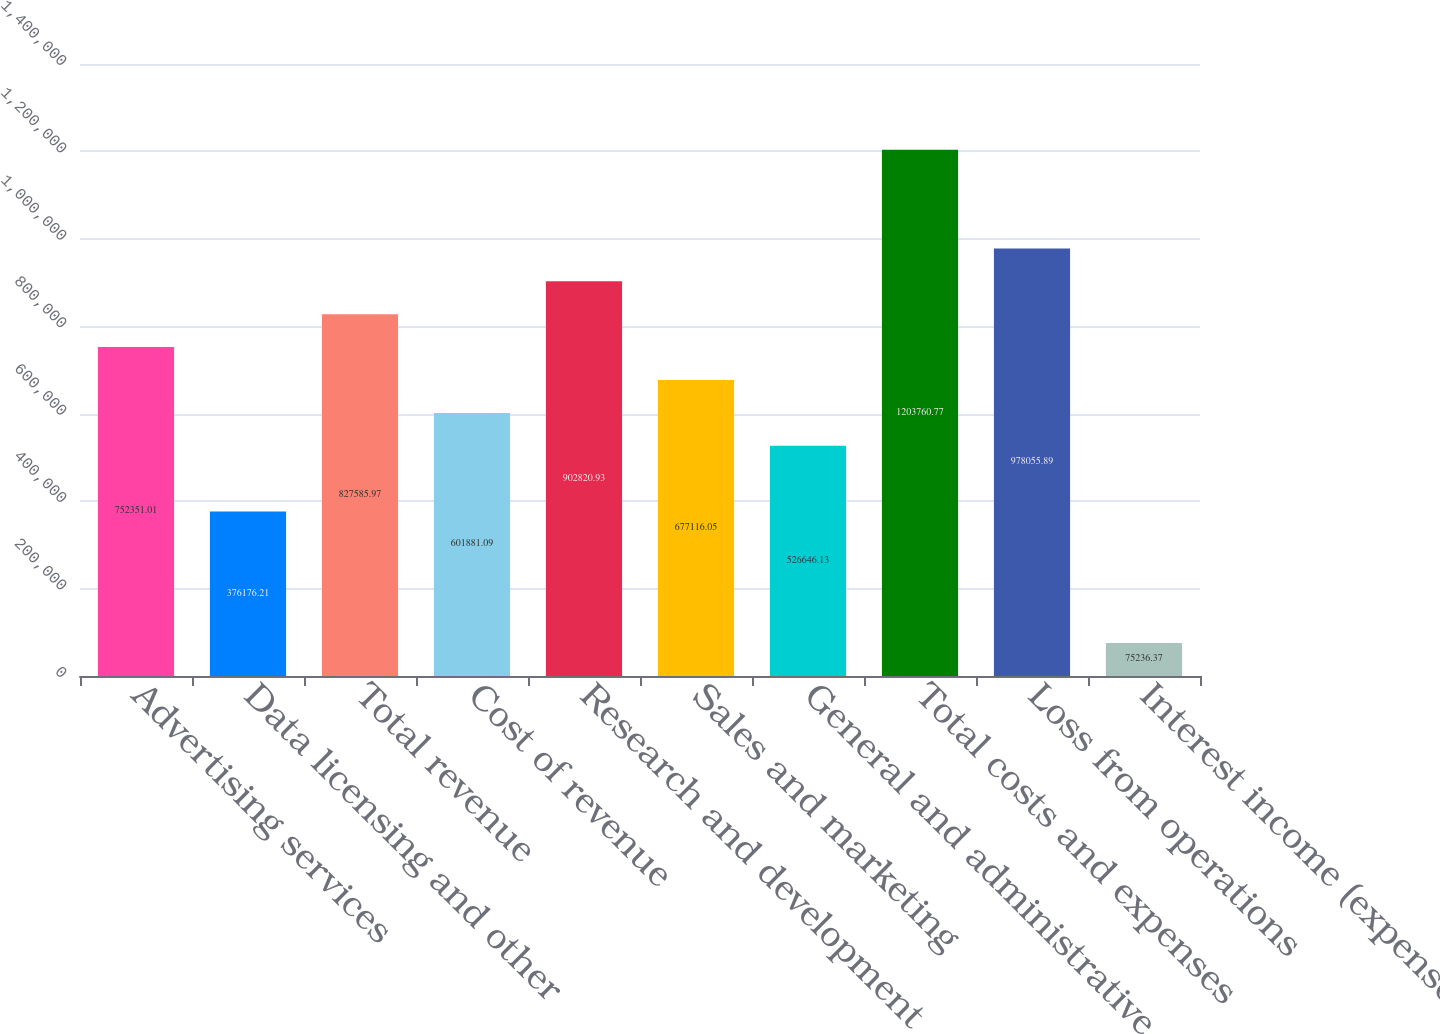<chart> <loc_0><loc_0><loc_500><loc_500><bar_chart><fcel>Advertising services<fcel>Data licensing and other<fcel>Total revenue<fcel>Cost of revenue<fcel>Research and development<fcel>Sales and marketing<fcel>General and administrative<fcel>Total costs and expenses<fcel>Loss from operations<fcel>Interest income (expense) net<nl><fcel>752351<fcel>376176<fcel>827586<fcel>601881<fcel>902821<fcel>677116<fcel>526646<fcel>1.20376e+06<fcel>978056<fcel>75236.4<nl></chart> 